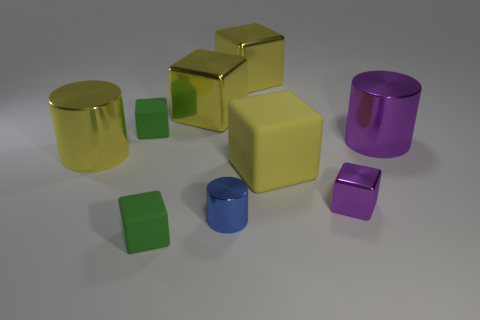Are there more blue metallic objects on the right side of the big yellow rubber thing than tiny cylinders?
Ensure brevity in your answer.  No. Do the tiny matte thing behind the large purple metallic object and the tiny purple shiny object have the same shape?
Give a very brief answer. Yes. Is there a cyan thing that has the same shape as the large purple object?
Ensure brevity in your answer.  No. What number of objects are either tiny blue objects on the left side of the big yellow matte block or blocks?
Keep it short and to the point. 7. Are there more blue metal cylinders than shiny spheres?
Offer a very short reply. Yes. Are there any purple shiny things of the same size as the purple metallic cylinder?
Keep it short and to the point. No. What number of things are either large shiny cylinders in front of the purple metal cylinder or big yellow objects that are behind the yellow rubber object?
Keep it short and to the point. 3. There is a large metallic cylinder in front of the cylinder that is behind the large yellow cylinder; what is its color?
Give a very brief answer. Yellow. There is another small thing that is the same material as the tiny purple thing; what is its color?
Keep it short and to the point. Blue. What number of cubes have the same color as the big rubber thing?
Provide a succinct answer. 2. 